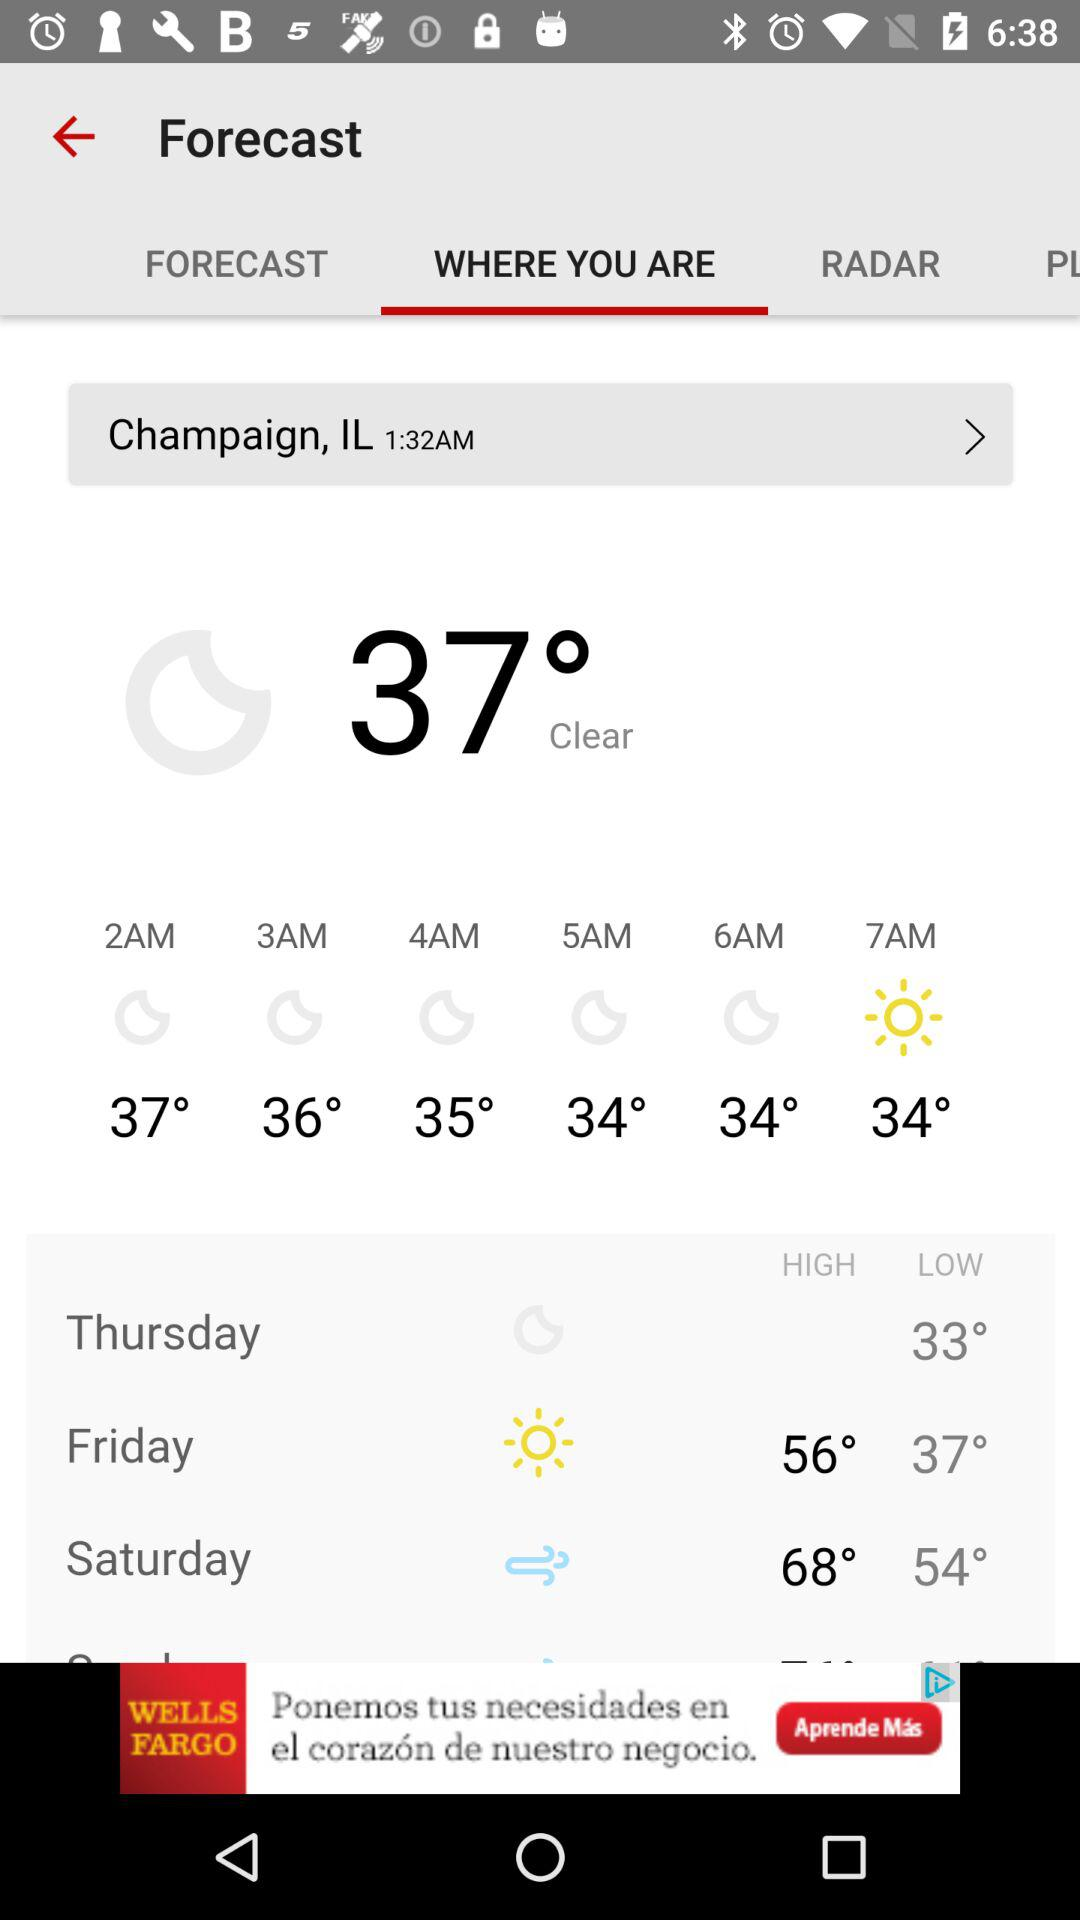Is the temperature high or low on Saturday?
When the provided information is insufficient, respond with <no answer>. <no answer> 